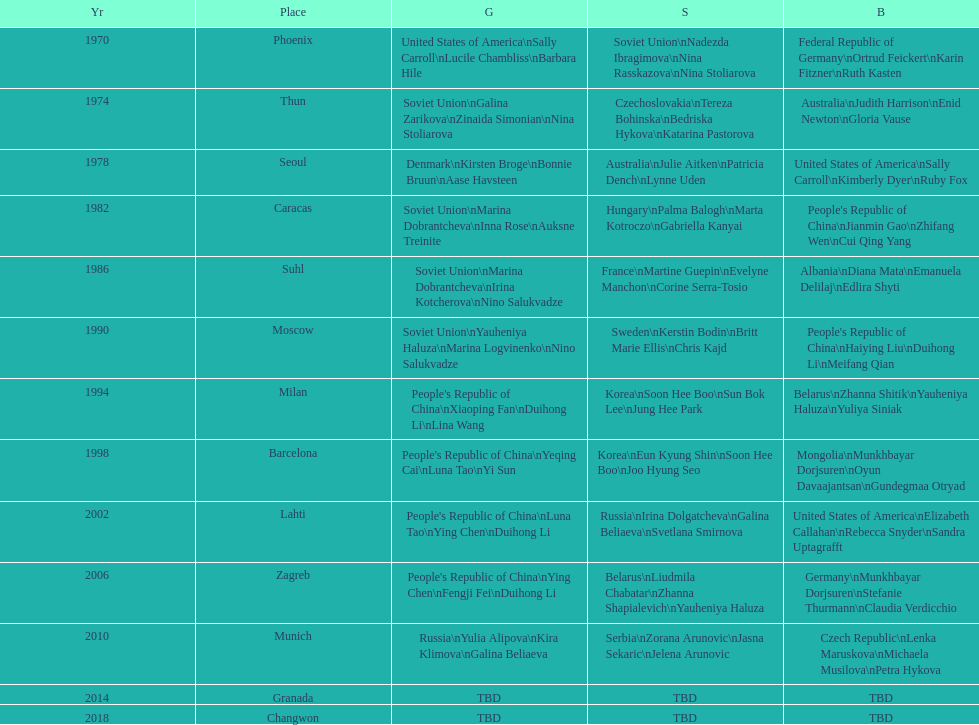Can you give me this table as a dict? {'header': ['Yr', 'Place', 'G', 'S', 'B'], 'rows': [['1970', 'Phoenix', 'United States of America\\nSally Carroll\\nLucile Chambliss\\nBarbara Hile', 'Soviet Union\\nNadezda Ibragimova\\nNina Rasskazova\\nNina Stoliarova', 'Federal Republic of Germany\\nOrtrud Feickert\\nKarin Fitzner\\nRuth Kasten'], ['1974', 'Thun', 'Soviet Union\\nGalina Zarikova\\nZinaida Simonian\\nNina Stoliarova', 'Czechoslovakia\\nTereza Bohinska\\nBedriska Hykova\\nKatarina Pastorova', 'Australia\\nJudith Harrison\\nEnid Newton\\nGloria Vause'], ['1978', 'Seoul', 'Denmark\\nKirsten Broge\\nBonnie Bruun\\nAase Havsteen', 'Australia\\nJulie Aitken\\nPatricia Dench\\nLynne Uden', 'United States of America\\nSally Carroll\\nKimberly Dyer\\nRuby Fox'], ['1982', 'Caracas', 'Soviet Union\\nMarina Dobrantcheva\\nInna Rose\\nAuksne Treinite', 'Hungary\\nPalma Balogh\\nMarta Kotroczo\\nGabriella Kanyai', "People's Republic of China\\nJianmin Gao\\nZhifang Wen\\nCui Qing Yang"], ['1986', 'Suhl', 'Soviet Union\\nMarina Dobrantcheva\\nIrina Kotcherova\\nNino Salukvadze', 'France\\nMartine Guepin\\nEvelyne Manchon\\nCorine Serra-Tosio', 'Albania\\nDiana Mata\\nEmanuela Delilaj\\nEdlira Shyti'], ['1990', 'Moscow', 'Soviet Union\\nYauheniya Haluza\\nMarina Logvinenko\\nNino Salukvadze', 'Sweden\\nKerstin Bodin\\nBritt Marie Ellis\\nChris Kajd', "People's Republic of China\\nHaiying Liu\\nDuihong Li\\nMeifang Qian"], ['1994', 'Milan', "People's Republic of China\\nXiaoping Fan\\nDuihong Li\\nLina Wang", 'Korea\\nSoon Hee Boo\\nSun Bok Lee\\nJung Hee Park', 'Belarus\\nZhanna Shitik\\nYauheniya Haluza\\nYuliya Siniak'], ['1998', 'Barcelona', "People's Republic of China\\nYeqing Cai\\nLuna Tao\\nYi Sun", 'Korea\\nEun Kyung Shin\\nSoon Hee Boo\\nJoo Hyung Seo', 'Mongolia\\nMunkhbayar Dorjsuren\\nOyun Davaajantsan\\nGundegmaa Otryad'], ['2002', 'Lahti', "People's Republic of China\\nLuna Tao\\nYing Chen\\nDuihong Li", 'Russia\\nIrina Dolgatcheva\\nGalina Beliaeva\\nSvetlana Smirnova', 'United States of America\\nElizabeth Callahan\\nRebecca Snyder\\nSandra Uptagrafft'], ['2006', 'Zagreb', "People's Republic of China\\nYing Chen\\nFengji Fei\\nDuihong Li", 'Belarus\\nLiudmila Chabatar\\nZhanna Shapialevich\\nYauheniya Haluza', 'Germany\\nMunkhbayar Dorjsuren\\nStefanie Thurmann\\nClaudia Verdicchio'], ['2010', 'Munich', 'Russia\\nYulia Alipova\\nKira Klimova\\nGalina Beliaeva', 'Serbia\\nZorana Arunovic\\nJasna Sekaric\\nJelena Arunovic', 'Czech Republic\\nLenka Maruskova\\nMichaela Musilova\\nPetra Hykova'], ['2014', 'Granada', 'TBD', 'TBD', 'TBD'], ['2018', 'Changwon', 'TBD', 'TBD', 'TBD']]} How many times has germany won bronze? 2. 